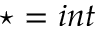<formula> <loc_0><loc_0><loc_500><loc_500>^ { * } = i n t</formula> 